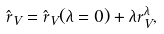Convert formula to latex. <formula><loc_0><loc_0><loc_500><loc_500>\hat { r } _ { V } = \hat { r } _ { V } ( \lambda = 0 ) + \lambda r _ { V } ^ { \lambda } ,</formula> 